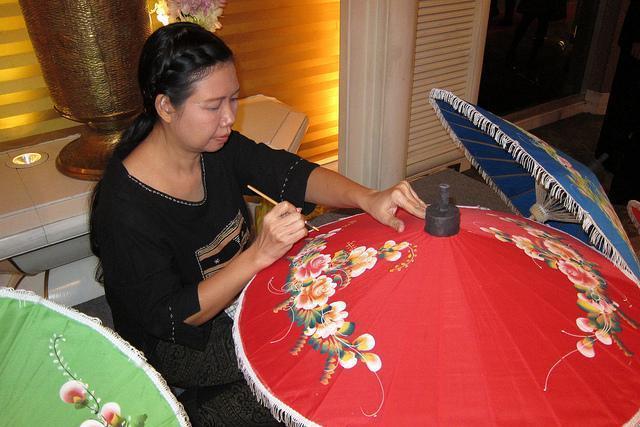How many umbrellas are there?
Give a very brief answer. 3. How many dark brown sheep are in the image?
Give a very brief answer. 0. 